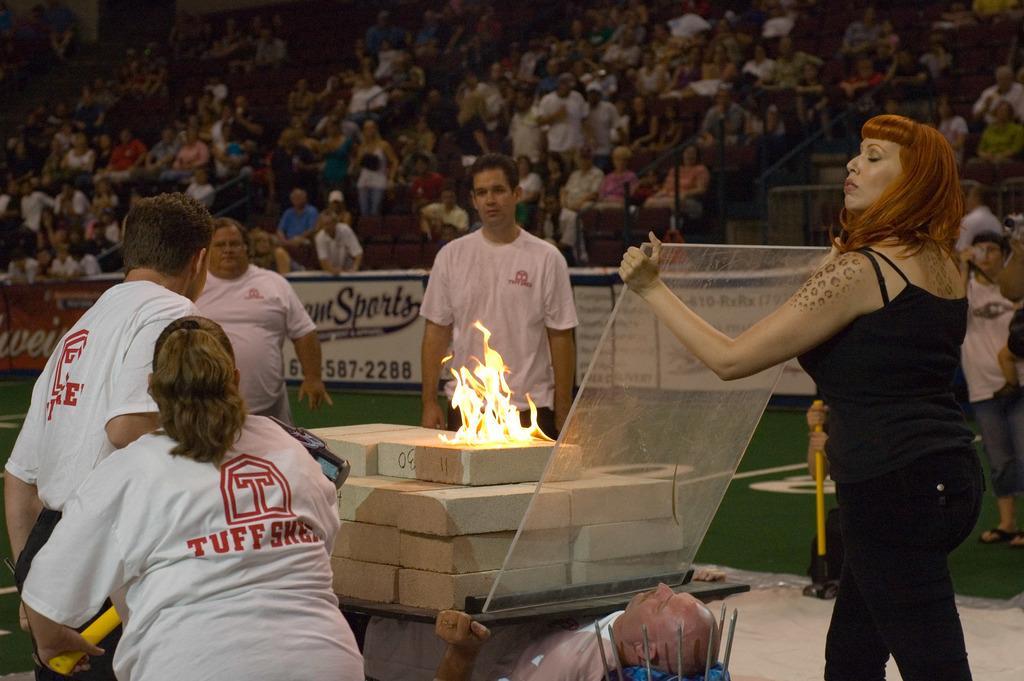Please provide a concise description of this image. This picture seems to be clicked inside the hall. In the foreground we can see a person lying and holding some objects and we can see the fire and we can see the bricks are placed on the top of the person. On the right there is a woman wearing black color T-shirt, standing and holding an object. On the left, we can see the group of people wearing white color T-shirt and seems to be standing. In the background, we can see the group of people seems to be sitting on the chairs and we can see the stairway, handrails, text on the banners and many other items. 